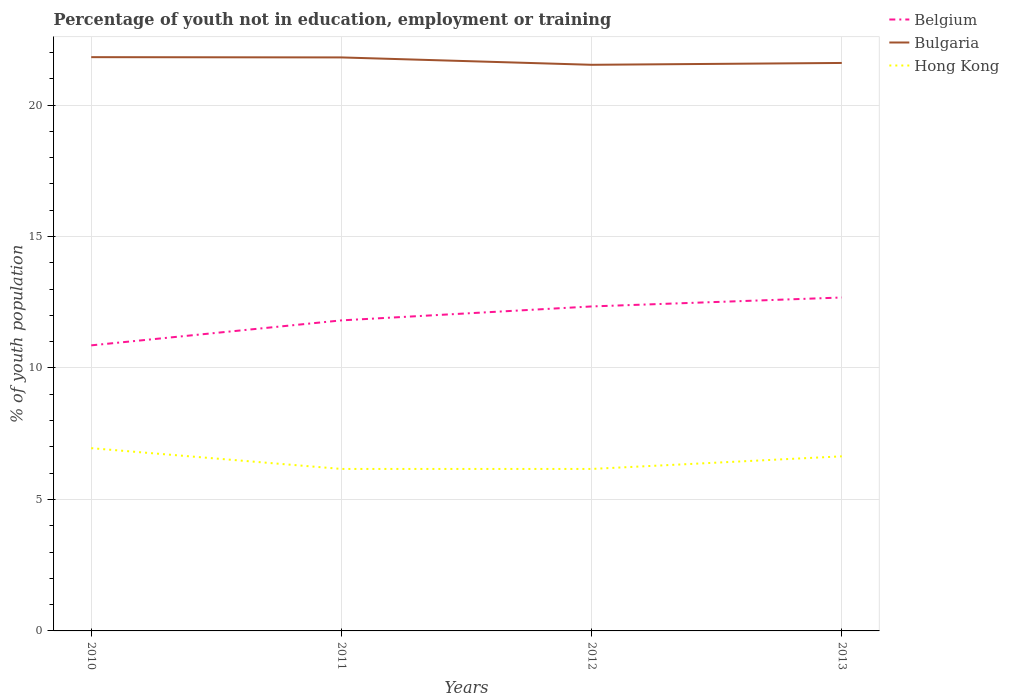How many different coloured lines are there?
Make the answer very short. 3. Does the line corresponding to Hong Kong intersect with the line corresponding to Belgium?
Keep it short and to the point. No. Across all years, what is the maximum percentage of unemployed youth population in in Belgium?
Offer a terse response. 10.86. In which year was the percentage of unemployed youth population in in Belgium maximum?
Your response must be concise. 2010. What is the total percentage of unemployed youth population in in Belgium in the graph?
Provide a short and direct response. -0.87. What is the difference between the highest and the second highest percentage of unemployed youth population in in Bulgaria?
Offer a very short reply. 0.29. What is the difference between the highest and the lowest percentage of unemployed youth population in in Bulgaria?
Your answer should be very brief. 2. Where does the legend appear in the graph?
Make the answer very short. Top right. How are the legend labels stacked?
Provide a succinct answer. Vertical. What is the title of the graph?
Provide a short and direct response. Percentage of youth not in education, employment or training. What is the label or title of the X-axis?
Your answer should be compact. Years. What is the label or title of the Y-axis?
Keep it short and to the point. % of youth population. What is the % of youth population of Belgium in 2010?
Provide a short and direct response. 10.86. What is the % of youth population of Bulgaria in 2010?
Your answer should be very brief. 21.82. What is the % of youth population of Hong Kong in 2010?
Your answer should be very brief. 6.95. What is the % of youth population of Belgium in 2011?
Keep it short and to the point. 11.81. What is the % of youth population in Bulgaria in 2011?
Make the answer very short. 21.81. What is the % of youth population of Hong Kong in 2011?
Keep it short and to the point. 6.16. What is the % of youth population in Belgium in 2012?
Keep it short and to the point. 12.34. What is the % of youth population of Bulgaria in 2012?
Keep it short and to the point. 21.53. What is the % of youth population of Hong Kong in 2012?
Keep it short and to the point. 6.16. What is the % of youth population in Belgium in 2013?
Give a very brief answer. 12.68. What is the % of youth population in Bulgaria in 2013?
Your response must be concise. 21.6. What is the % of youth population of Hong Kong in 2013?
Keep it short and to the point. 6.64. Across all years, what is the maximum % of youth population in Belgium?
Provide a short and direct response. 12.68. Across all years, what is the maximum % of youth population in Bulgaria?
Keep it short and to the point. 21.82. Across all years, what is the maximum % of youth population of Hong Kong?
Offer a terse response. 6.95. Across all years, what is the minimum % of youth population in Belgium?
Keep it short and to the point. 10.86. Across all years, what is the minimum % of youth population of Bulgaria?
Make the answer very short. 21.53. Across all years, what is the minimum % of youth population of Hong Kong?
Offer a terse response. 6.16. What is the total % of youth population in Belgium in the graph?
Ensure brevity in your answer.  47.69. What is the total % of youth population in Bulgaria in the graph?
Offer a very short reply. 86.76. What is the total % of youth population in Hong Kong in the graph?
Give a very brief answer. 25.91. What is the difference between the % of youth population in Belgium in 2010 and that in 2011?
Your response must be concise. -0.95. What is the difference between the % of youth population in Hong Kong in 2010 and that in 2011?
Offer a very short reply. 0.79. What is the difference between the % of youth population of Belgium in 2010 and that in 2012?
Provide a succinct answer. -1.48. What is the difference between the % of youth population of Bulgaria in 2010 and that in 2012?
Give a very brief answer. 0.29. What is the difference between the % of youth population in Hong Kong in 2010 and that in 2012?
Ensure brevity in your answer.  0.79. What is the difference between the % of youth population in Belgium in 2010 and that in 2013?
Your answer should be very brief. -1.82. What is the difference between the % of youth population in Bulgaria in 2010 and that in 2013?
Your answer should be very brief. 0.22. What is the difference between the % of youth population in Hong Kong in 2010 and that in 2013?
Your answer should be compact. 0.31. What is the difference between the % of youth population in Belgium in 2011 and that in 2012?
Your answer should be very brief. -0.53. What is the difference between the % of youth population of Bulgaria in 2011 and that in 2012?
Make the answer very short. 0.28. What is the difference between the % of youth population of Hong Kong in 2011 and that in 2012?
Offer a terse response. 0. What is the difference between the % of youth population in Belgium in 2011 and that in 2013?
Offer a terse response. -0.87. What is the difference between the % of youth population of Bulgaria in 2011 and that in 2013?
Offer a very short reply. 0.21. What is the difference between the % of youth population of Hong Kong in 2011 and that in 2013?
Offer a terse response. -0.48. What is the difference between the % of youth population of Belgium in 2012 and that in 2013?
Give a very brief answer. -0.34. What is the difference between the % of youth population in Bulgaria in 2012 and that in 2013?
Offer a terse response. -0.07. What is the difference between the % of youth population in Hong Kong in 2012 and that in 2013?
Offer a terse response. -0.48. What is the difference between the % of youth population of Belgium in 2010 and the % of youth population of Bulgaria in 2011?
Offer a very short reply. -10.95. What is the difference between the % of youth population of Bulgaria in 2010 and the % of youth population of Hong Kong in 2011?
Offer a terse response. 15.66. What is the difference between the % of youth population in Belgium in 2010 and the % of youth population in Bulgaria in 2012?
Provide a succinct answer. -10.67. What is the difference between the % of youth population of Bulgaria in 2010 and the % of youth population of Hong Kong in 2012?
Provide a succinct answer. 15.66. What is the difference between the % of youth population of Belgium in 2010 and the % of youth population of Bulgaria in 2013?
Give a very brief answer. -10.74. What is the difference between the % of youth population in Belgium in 2010 and the % of youth population in Hong Kong in 2013?
Your answer should be very brief. 4.22. What is the difference between the % of youth population of Bulgaria in 2010 and the % of youth population of Hong Kong in 2013?
Provide a succinct answer. 15.18. What is the difference between the % of youth population of Belgium in 2011 and the % of youth population of Bulgaria in 2012?
Keep it short and to the point. -9.72. What is the difference between the % of youth population of Belgium in 2011 and the % of youth population of Hong Kong in 2012?
Ensure brevity in your answer.  5.65. What is the difference between the % of youth population in Bulgaria in 2011 and the % of youth population in Hong Kong in 2012?
Your answer should be very brief. 15.65. What is the difference between the % of youth population of Belgium in 2011 and the % of youth population of Bulgaria in 2013?
Offer a very short reply. -9.79. What is the difference between the % of youth population in Belgium in 2011 and the % of youth population in Hong Kong in 2013?
Make the answer very short. 5.17. What is the difference between the % of youth population of Bulgaria in 2011 and the % of youth population of Hong Kong in 2013?
Your response must be concise. 15.17. What is the difference between the % of youth population in Belgium in 2012 and the % of youth population in Bulgaria in 2013?
Your answer should be compact. -9.26. What is the difference between the % of youth population in Bulgaria in 2012 and the % of youth population in Hong Kong in 2013?
Offer a terse response. 14.89. What is the average % of youth population of Belgium per year?
Offer a very short reply. 11.92. What is the average % of youth population of Bulgaria per year?
Offer a terse response. 21.69. What is the average % of youth population of Hong Kong per year?
Offer a very short reply. 6.48. In the year 2010, what is the difference between the % of youth population in Belgium and % of youth population in Bulgaria?
Keep it short and to the point. -10.96. In the year 2010, what is the difference between the % of youth population of Belgium and % of youth population of Hong Kong?
Offer a terse response. 3.91. In the year 2010, what is the difference between the % of youth population in Bulgaria and % of youth population in Hong Kong?
Keep it short and to the point. 14.87. In the year 2011, what is the difference between the % of youth population in Belgium and % of youth population in Bulgaria?
Offer a very short reply. -10. In the year 2011, what is the difference between the % of youth population in Belgium and % of youth population in Hong Kong?
Your answer should be very brief. 5.65. In the year 2011, what is the difference between the % of youth population in Bulgaria and % of youth population in Hong Kong?
Make the answer very short. 15.65. In the year 2012, what is the difference between the % of youth population in Belgium and % of youth population in Bulgaria?
Your answer should be very brief. -9.19. In the year 2012, what is the difference between the % of youth population in Belgium and % of youth population in Hong Kong?
Make the answer very short. 6.18. In the year 2012, what is the difference between the % of youth population of Bulgaria and % of youth population of Hong Kong?
Give a very brief answer. 15.37. In the year 2013, what is the difference between the % of youth population in Belgium and % of youth population in Bulgaria?
Your answer should be very brief. -8.92. In the year 2013, what is the difference between the % of youth population in Belgium and % of youth population in Hong Kong?
Make the answer very short. 6.04. In the year 2013, what is the difference between the % of youth population in Bulgaria and % of youth population in Hong Kong?
Offer a very short reply. 14.96. What is the ratio of the % of youth population of Belgium in 2010 to that in 2011?
Provide a short and direct response. 0.92. What is the ratio of the % of youth population in Hong Kong in 2010 to that in 2011?
Keep it short and to the point. 1.13. What is the ratio of the % of youth population in Belgium in 2010 to that in 2012?
Your answer should be very brief. 0.88. What is the ratio of the % of youth population of Bulgaria in 2010 to that in 2012?
Provide a short and direct response. 1.01. What is the ratio of the % of youth population of Hong Kong in 2010 to that in 2012?
Ensure brevity in your answer.  1.13. What is the ratio of the % of youth population of Belgium in 2010 to that in 2013?
Provide a short and direct response. 0.86. What is the ratio of the % of youth population in Bulgaria in 2010 to that in 2013?
Make the answer very short. 1.01. What is the ratio of the % of youth population in Hong Kong in 2010 to that in 2013?
Provide a short and direct response. 1.05. What is the ratio of the % of youth population in Belgium in 2011 to that in 2012?
Ensure brevity in your answer.  0.96. What is the ratio of the % of youth population in Bulgaria in 2011 to that in 2012?
Keep it short and to the point. 1.01. What is the ratio of the % of youth population in Belgium in 2011 to that in 2013?
Provide a short and direct response. 0.93. What is the ratio of the % of youth population in Bulgaria in 2011 to that in 2013?
Provide a succinct answer. 1.01. What is the ratio of the % of youth population of Hong Kong in 2011 to that in 2013?
Keep it short and to the point. 0.93. What is the ratio of the % of youth population of Belgium in 2012 to that in 2013?
Ensure brevity in your answer.  0.97. What is the ratio of the % of youth population in Bulgaria in 2012 to that in 2013?
Make the answer very short. 1. What is the ratio of the % of youth population in Hong Kong in 2012 to that in 2013?
Provide a succinct answer. 0.93. What is the difference between the highest and the second highest % of youth population in Belgium?
Your answer should be very brief. 0.34. What is the difference between the highest and the second highest % of youth population of Hong Kong?
Your answer should be very brief. 0.31. What is the difference between the highest and the lowest % of youth population of Belgium?
Give a very brief answer. 1.82. What is the difference between the highest and the lowest % of youth population of Bulgaria?
Provide a succinct answer. 0.29. What is the difference between the highest and the lowest % of youth population of Hong Kong?
Offer a terse response. 0.79. 